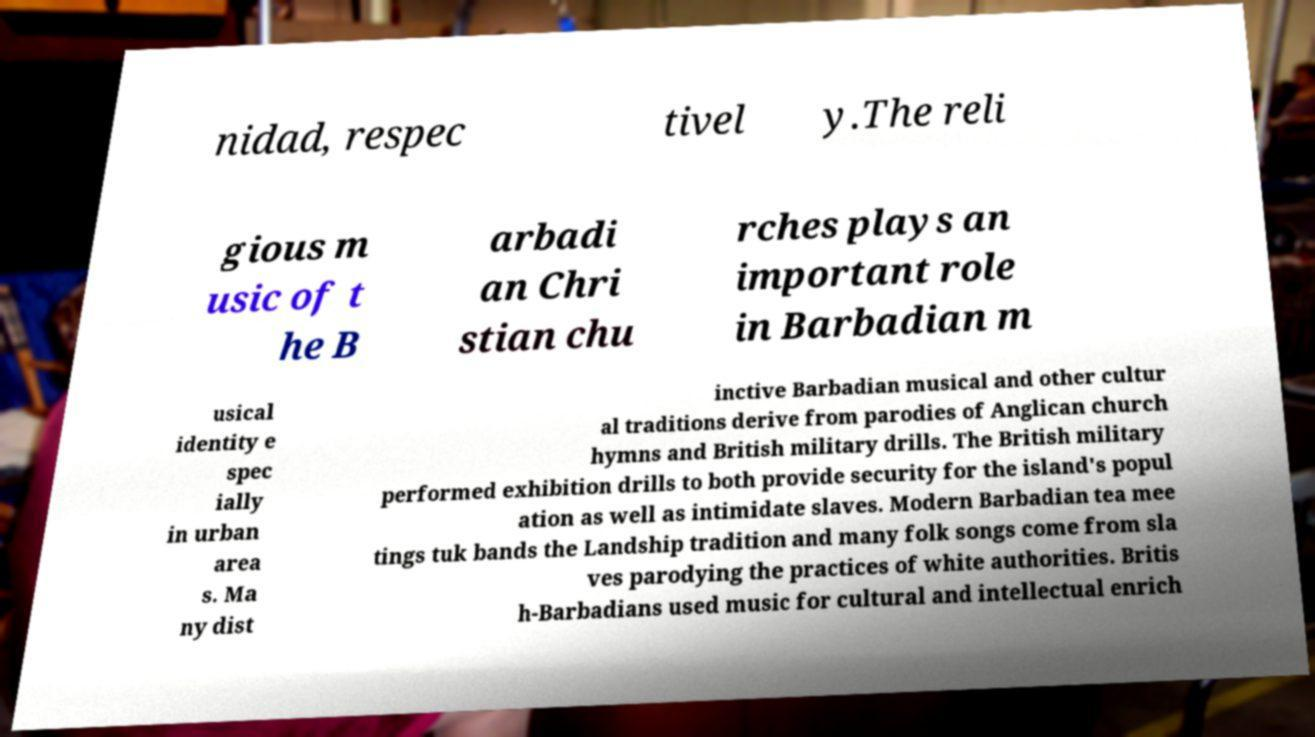I need the written content from this picture converted into text. Can you do that? nidad, respec tivel y.The reli gious m usic of t he B arbadi an Chri stian chu rches plays an important role in Barbadian m usical identity e spec ially in urban area s. Ma ny dist inctive Barbadian musical and other cultur al traditions derive from parodies of Anglican church hymns and British military drills. The British military performed exhibition drills to both provide security for the island's popul ation as well as intimidate slaves. Modern Barbadian tea mee tings tuk bands the Landship tradition and many folk songs come from sla ves parodying the practices of white authorities. Britis h-Barbadians used music for cultural and intellectual enrich 